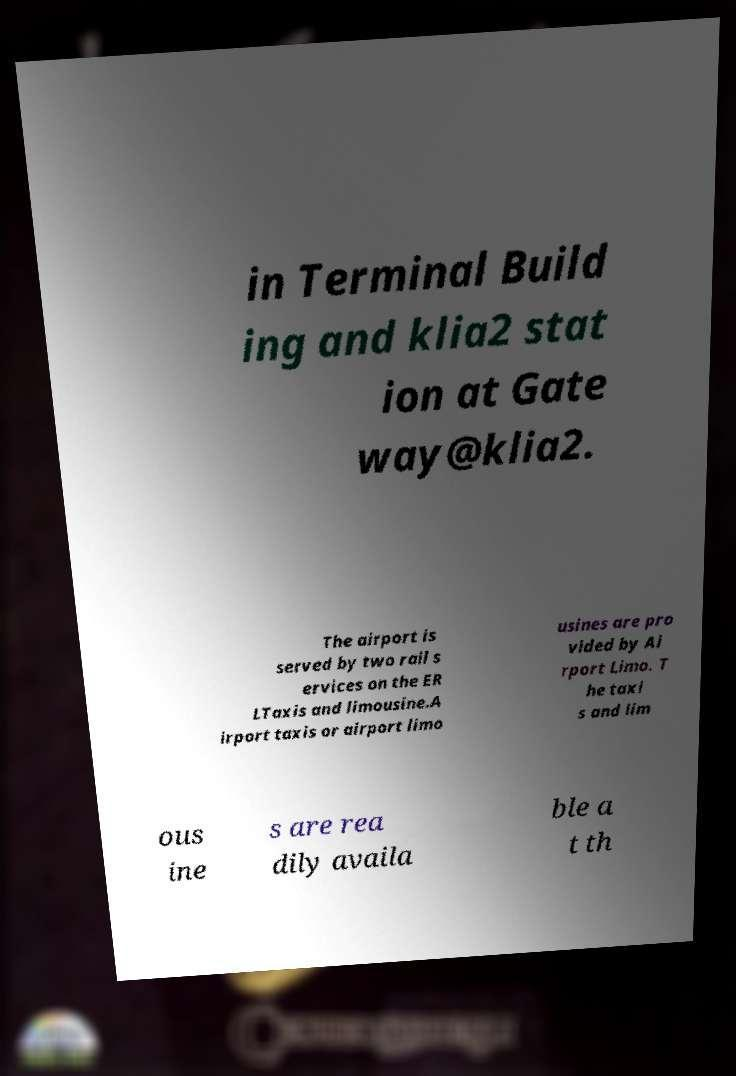There's text embedded in this image that I need extracted. Can you transcribe it verbatim? in Terminal Build ing and klia2 stat ion at Gate way@klia2. The airport is served by two rail s ervices on the ER LTaxis and limousine.A irport taxis or airport limo usines are pro vided by Ai rport Limo. T he taxi s and lim ous ine s are rea dily availa ble a t th 